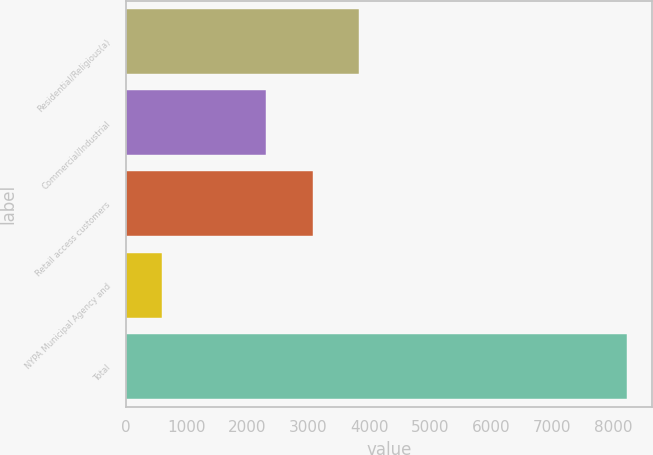<chart> <loc_0><loc_0><loc_500><loc_500><bar_chart><fcel>Residential/Religious(a)<fcel>Commercial/Industrial<fcel>Retail access customers<fcel>NYPA Municipal Agency and<fcel>Total<nl><fcel>3831.2<fcel>2304<fcel>3067.6<fcel>592<fcel>8228<nl></chart> 